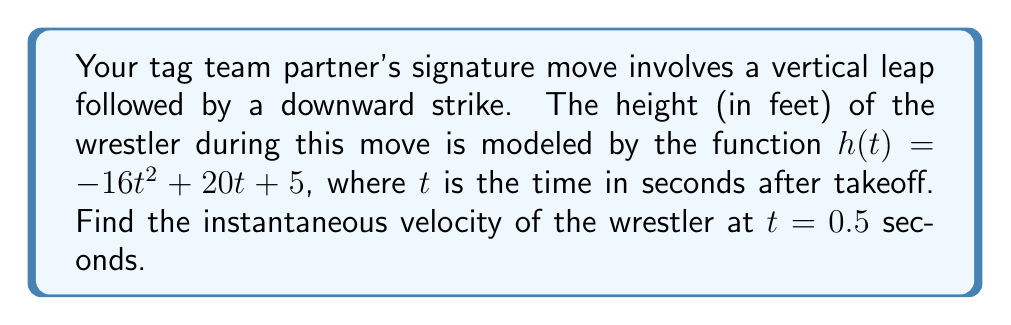Can you answer this question? To find the instantaneous velocity, we need to calculate the derivative of the position function and evaluate it at the given time.

1. The height function is given as:
   $h(t) = -16t^2 + 20t + 5$

2. The velocity function is the derivative of the height function:
   $v(t) = \frac{d}{dt}h(t) = -32t + 20$

3. We need to find the velocity at $t = 0.5$ seconds:
   $v(0.5) = -32(0.5) + 20$
   $v(0.5) = -16 + 20 = 4$

4. The units of velocity are feet per second (ft/s), as the height is in feet and time is in seconds.

Therefore, the instantaneous velocity of the wrestler at $t = 0.5$ seconds is 4 ft/s.
Answer: 4 ft/s 